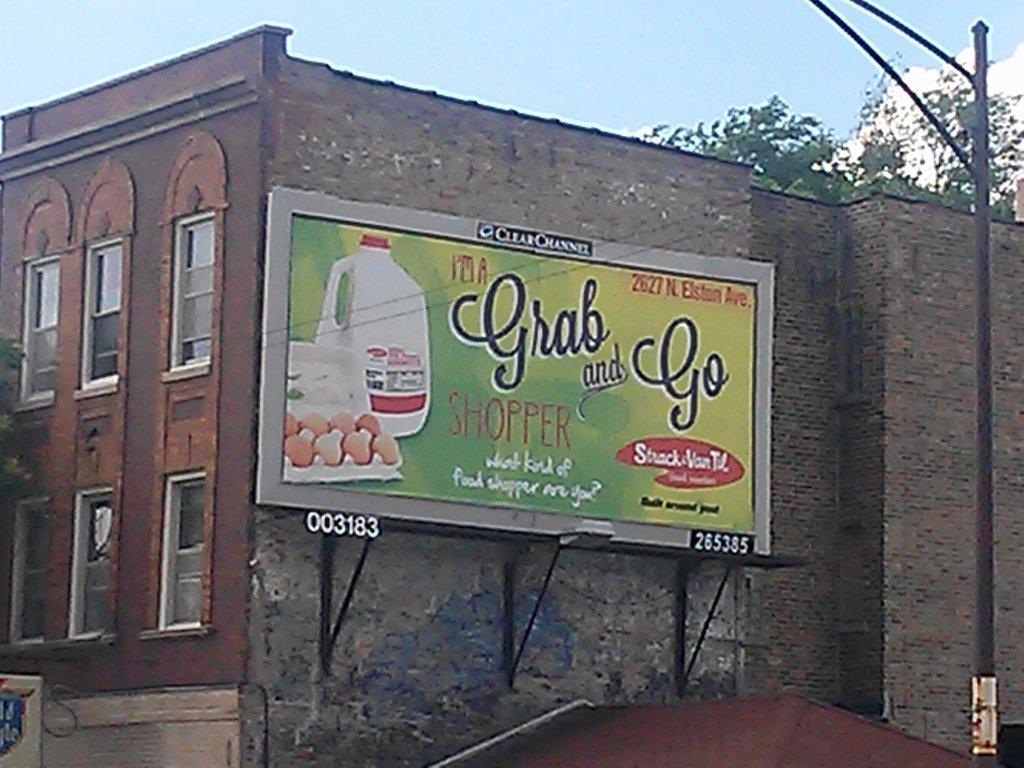<image>
Offer a succinct explanation of the picture presented. A billboard on the side of a building advertising 'Grab and Go' 